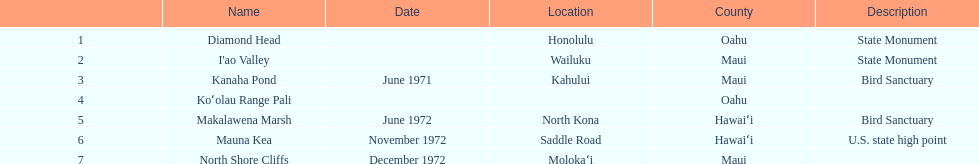Which county is featured the most on the chart? Maui. 